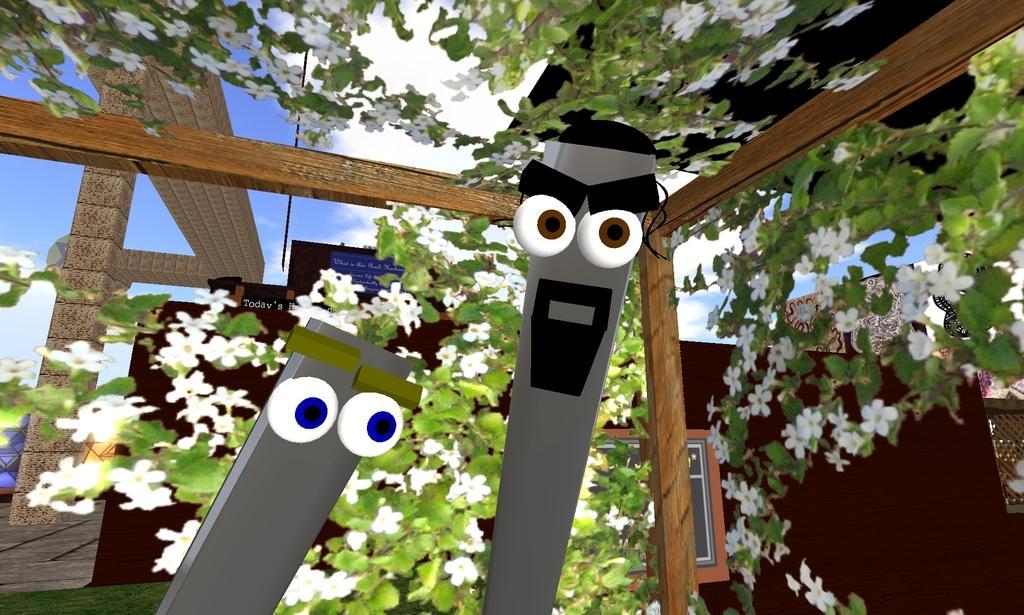Could you give a brief overview of what you see in this image? In this animated image I can see some wooden objects, a window, a wall some poles and pillars a tree with some flowers, and there are two objects in the center of the image with eyes and eyebrows. 